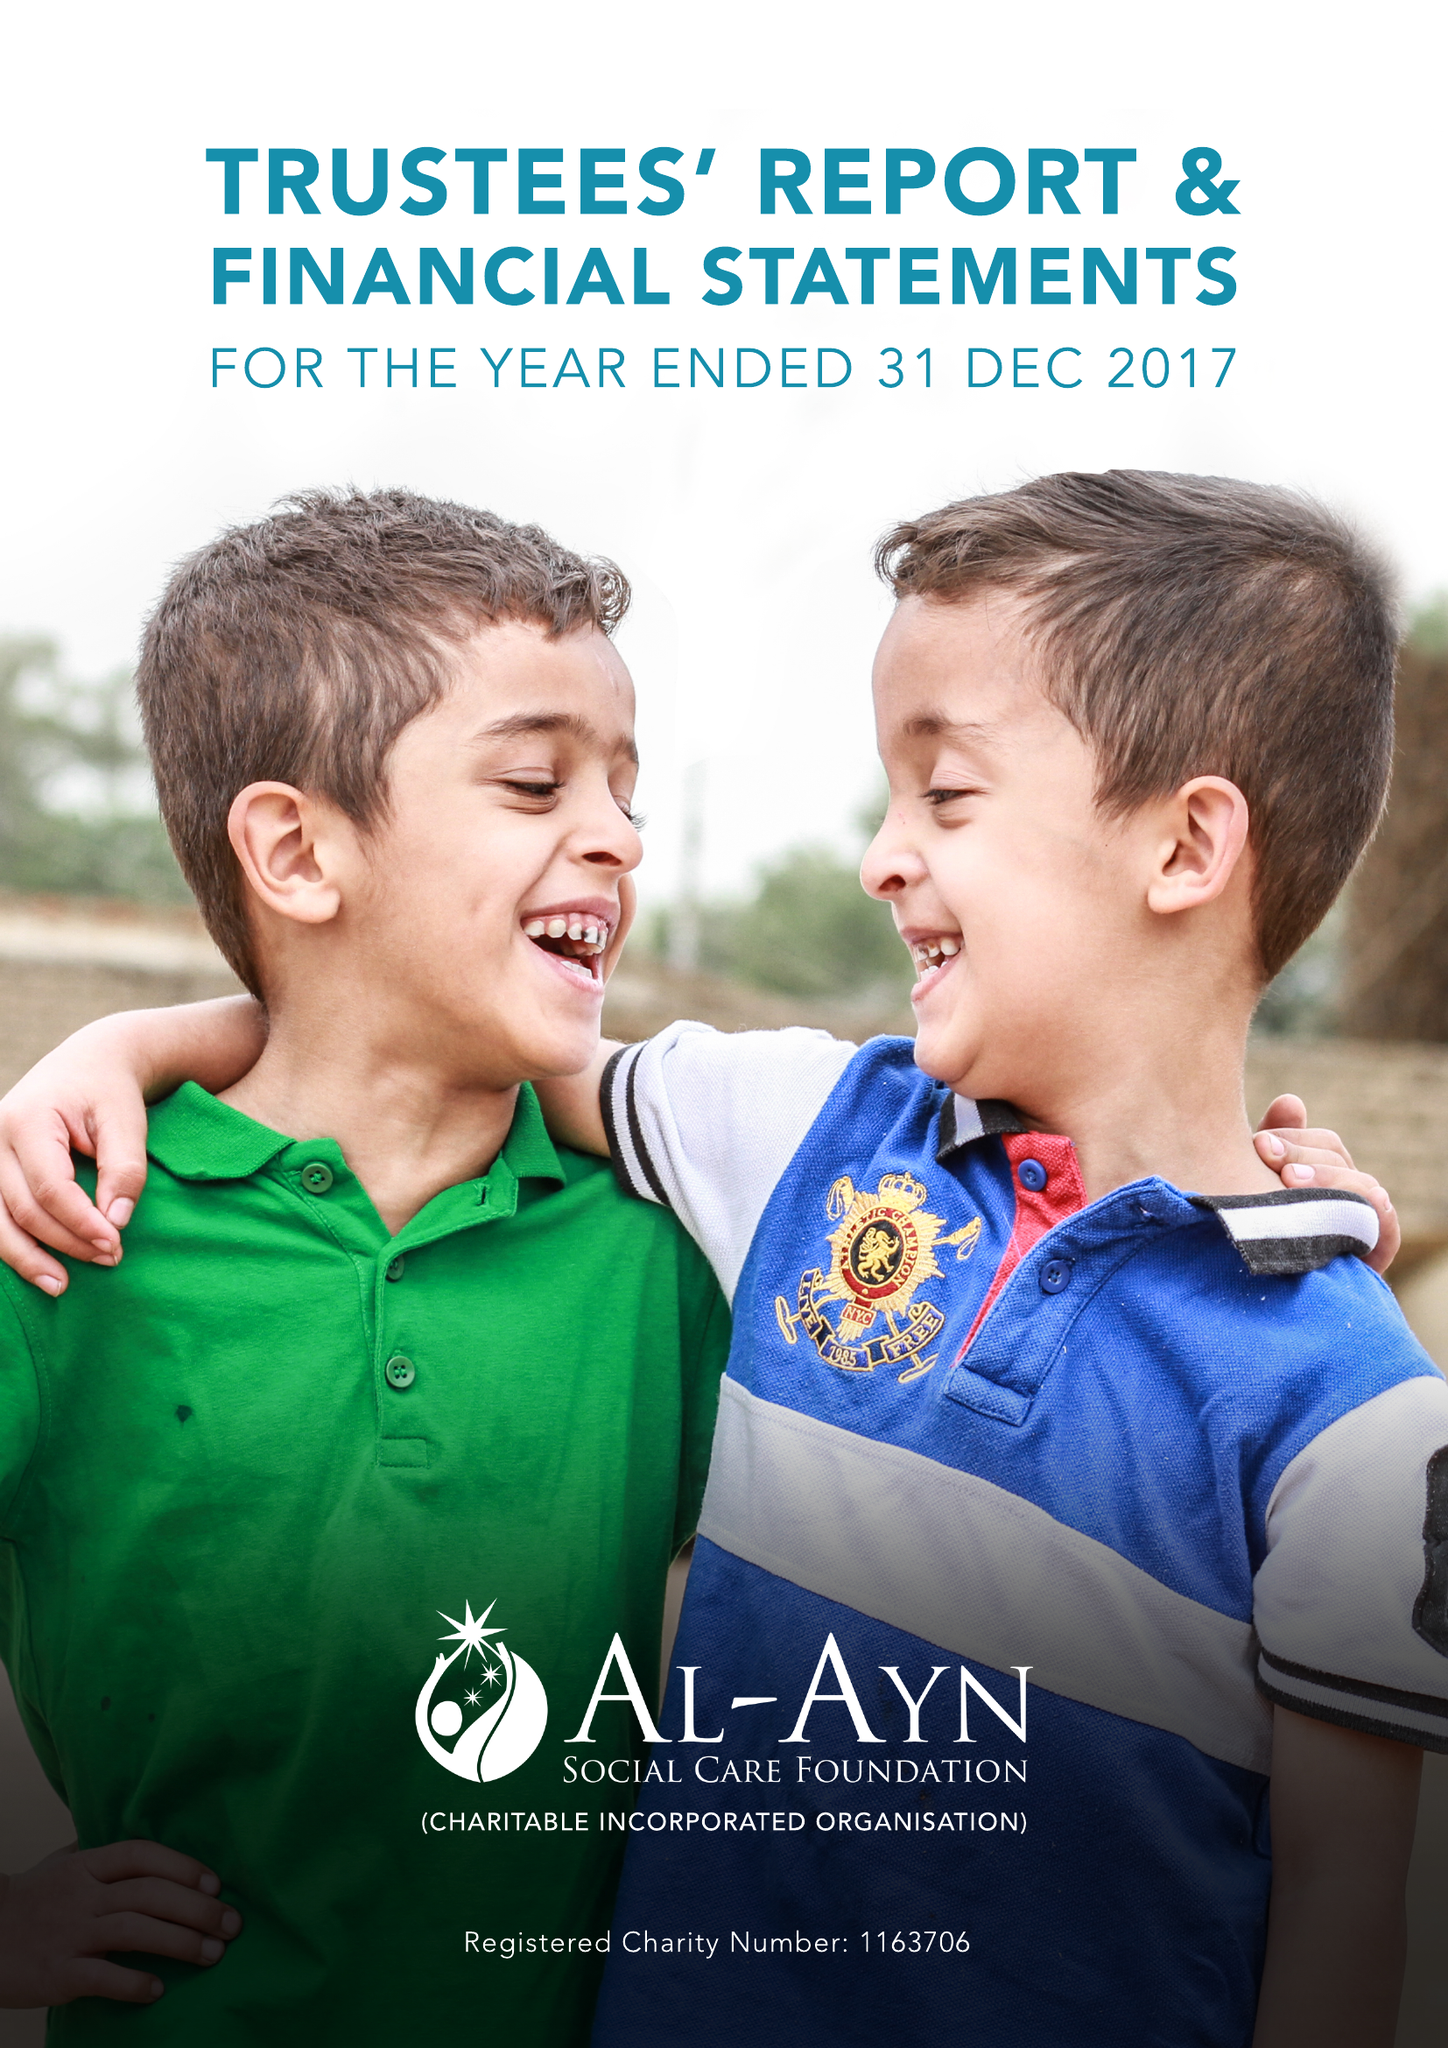What is the value for the address__street_line?
Answer the question using a single word or phrase. 297-303 EDGWARE ROAD 